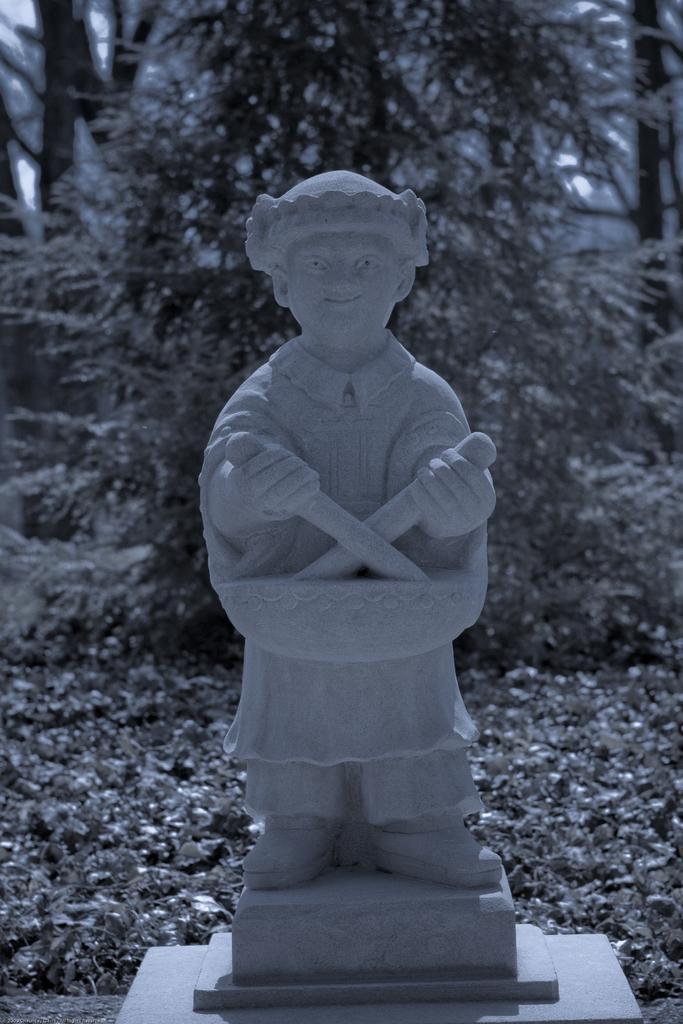Can you describe this image briefly? In this image there is a sculpture of a man. He is holding knives in his hand. Behind him there are trees on the ground. 